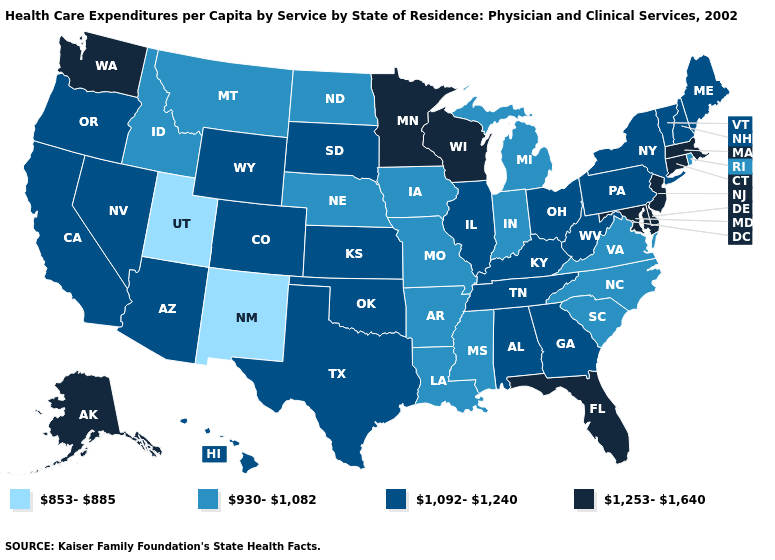Does Kansas have the same value as Pennsylvania?
Be succinct. Yes. What is the value of Kentucky?
Answer briefly. 1,092-1,240. Name the states that have a value in the range 930-1,082?
Be succinct. Arkansas, Idaho, Indiana, Iowa, Louisiana, Michigan, Mississippi, Missouri, Montana, Nebraska, North Carolina, North Dakota, Rhode Island, South Carolina, Virginia. What is the lowest value in the MidWest?
Keep it brief. 930-1,082. Does Montana have a higher value than Rhode Island?
Write a very short answer. No. What is the value of Wyoming?
Keep it brief. 1,092-1,240. Among the states that border Wyoming , does Colorado have the highest value?
Answer briefly. Yes. What is the value of Washington?
Write a very short answer. 1,253-1,640. Does Arkansas have the highest value in the USA?
Short answer required. No. What is the value of New York?
Concise answer only. 1,092-1,240. What is the value of New Hampshire?
Short answer required. 1,092-1,240. What is the lowest value in states that border New Hampshire?
Concise answer only. 1,092-1,240. Is the legend a continuous bar?
Be succinct. No. Which states have the lowest value in the South?
Keep it brief. Arkansas, Louisiana, Mississippi, North Carolina, South Carolina, Virginia. What is the value of Washington?
Answer briefly. 1,253-1,640. 